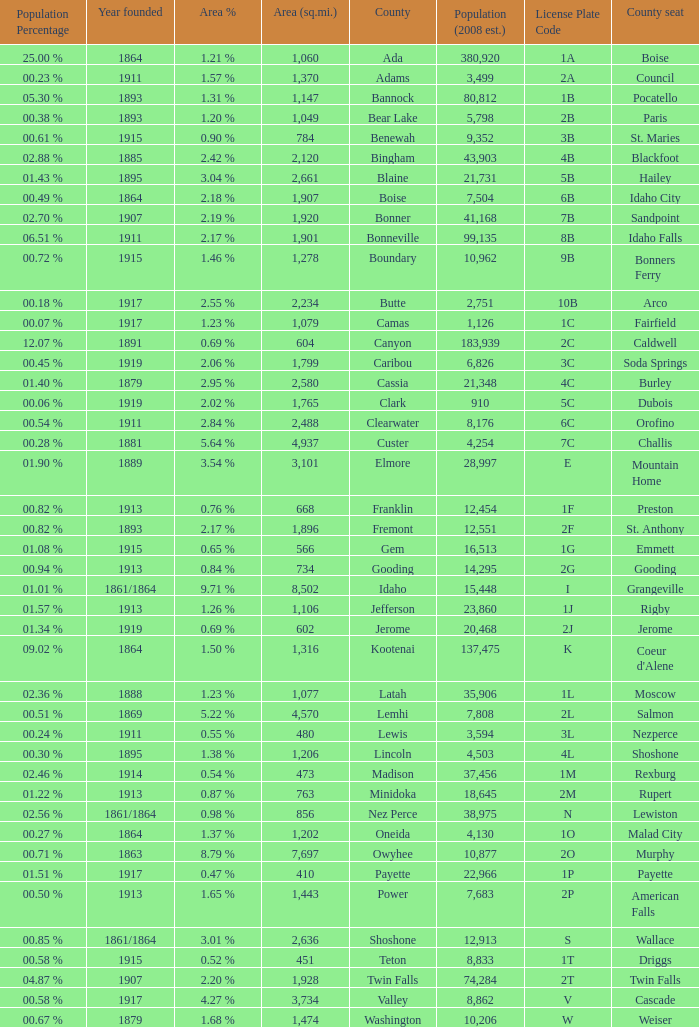What is the license plate code for the country with an area of 784? 3B. Write the full table. {'header': ['Population Percentage', 'Year founded', 'Area %', 'Area (sq.mi.)', 'County', 'Population (2008 est.)', 'License Plate Code', 'County seat'], 'rows': [['25.00 %', '1864', '1.21 %', '1,060', 'Ada', '380,920', '1A', 'Boise'], ['00.23 %', '1911', '1.57 %', '1,370', 'Adams', '3,499', '2A', 'Council'], ['05.30 %', '1893', '1.31 %', '1,147', 'Bannock', '80,812', '1B', 'Pocatello'], ['00.38 %', '1893', '1.20 %', '1,049', 'Bear Lake', '5,798', '2B', 'Paris'], ['00.61 %', '1915', '0.90 %', '784', 'Benewah', '9,352', '3B', 'St. Maries'], ['02.88 %', '1885', '2.42 %', '2,120', 'Bingham', '43,903', '4B', 'Blackfoot'], ['01.43 %', '1895', '3.04 %', '2,661', 'Blaine', '21,731', '5B', 'Hailey'], ['00.49 %', '1864', '2.18 %', '1,907', 'Boise', '7,504', '6B', 'Idaho City'], ['02.70 %', '1907', '2.19 %', '1,920', 'Bonner', '41,168', '7B', 'Sandpoint'], ['06.51 %', '1911', '2.17 %', '1,901', 'Bonneville', '99,135', '8B', 'Idaho Falls'], ['00.72 %', '1915', '1.46 %', '1,278', 'Boundary', '10,962', '9B', 'Bonners Ferry'], ['00.18 %', '1917', '2.55 %', '2,234', 'Butte', '2,751', '10B', 'Arco'], ['00.07 %', '1917', '1.23 %', '1,079', 'Camas', '1,126', '1C', 'Fairfield'], ['12.07 %', '1891', '0.69 %', '604', 'Canyon', '183,939', '2C', 'Caldwell'], ['00.45 %', '1919', '2.06 %', '1,799', 'Caribou', '6,826', '3C', 'Soda Springs'], ['01.40 %', '1879', '2.95 %', '2,580', 'Cassia', '21,348', '4C', 'Burley'], ['00.06 %', '1919', '2.02 %', '1,765', 'Clark', '910', '5C', 'Dubois'], ['00.54 %', '1911', '2.84 %', '2,488', 'Clearwater', '8,176', '6C', 'Orofino'], ['00.28 %', '1881', '5.64 %', '4,937', 'Custer', '4,254', '7C', 'Challis'], ['01.90 %', '1889', '3.54 %', '3,101', 'Elmore', '28,997', 'E', 'Mountain Home'], ['00.82 %', '1913', '0.76 %', '668', 'Franklin', '12,454', '1F', 'Preston'], ['00.82 %', '1893', '2.17 %', '1,896', 'Fremont', '12,551', '2F', 'St. Anthony'], ['01.08 %', '1915', '0.65 %', '566', 'Gem', '16,513', '1G', 'Emmett'], ['00.94 %', '1913', '0.84 %', '734', 'Gooding', '14,295', '2G', 'Gooding'], ['01.01 %', '1861/1864', '9.71 %', '8,502', 'Idaho', '15,448', 'I', 'Grangeville'], ['01.57 %', '1913', '1.26 %', '1,106', 'Jefferson', '23,860', '1J', 'Rigby'], ['01.34 %', '1919', '0.69 %', '602', 'Jerome', '20,468', '2J', 'Jerome'], ['09.02 %', '1864', '1.50 %', '1,316', 'Kootenai', '137,475', 'K', "Coeur d'Alene"], ['02.36 %', '1888', '1.23 %', '1,077', 'Latah', '35,906', '1L', 'Moscow'], ['00.51 %', '1869', '5.22 %', '4,570', 'Lemhi', '7,808', '2L', 'Salmon'], ['00.24 %', '1911', '0.55 %', '480', 'Lewis', '3,594', '3L', 'Nezperce'], ['00.30 %', '1895', '1.38 %', '1,206', 'Lincoln', '4,503', '4L', 'Shoshone'], ['02.46 %', '1914', '0.54 %', '473', 'Madison', '37,456', '1M', 'Rexburg'], ['01.22 %', '1913', '0.87 %', '763', 'Minidoka', '18,645', '2M', 'Rupert'], ['02.56 %', '1861/1864', '0.98 %', '856', 'Nez Perce', '38,975', 'N', 'Lewiston'], ['00.27 %', '1864', '1.37 %', '1,202', 'Oneida', '4,130', '1O', 'Malad City'], ['00.71 %', '1863', '8.79 %', '7,697', 'Owyhee', '10,877', '2O', 'Murphy'], ['01.51 %', '1917', '0.47 %', '410', 'Payette', '22,966', '1P', 'Payette'], ['00.50 %', '1913', '1.65 %', '1,443', 'Power', '7,683', '2P', 'American Falls'], ['00.85 %', '1861/1864', '3.01 %', '2,636', 'Shoshone', '12,913', 'S', 'Wallace'], ['00.58 %', '1915', '0.52 %', '451', 'Teton', '8,833', '1T', 'Driggs'], ['04.87 %', '1907', '2.20 %', '1,928', 'Twin Falls', '74,284', '2T', 'Twin Falls'], ['00.58 %', '1917', '4.27 %', '3,734', 'Valley', '8,862', 'V', 'Cascade'], ['00.67 %', '1879', '1.68 %', '1,474', 'Washington', '10,206', 'W', 'Weiser']]} 